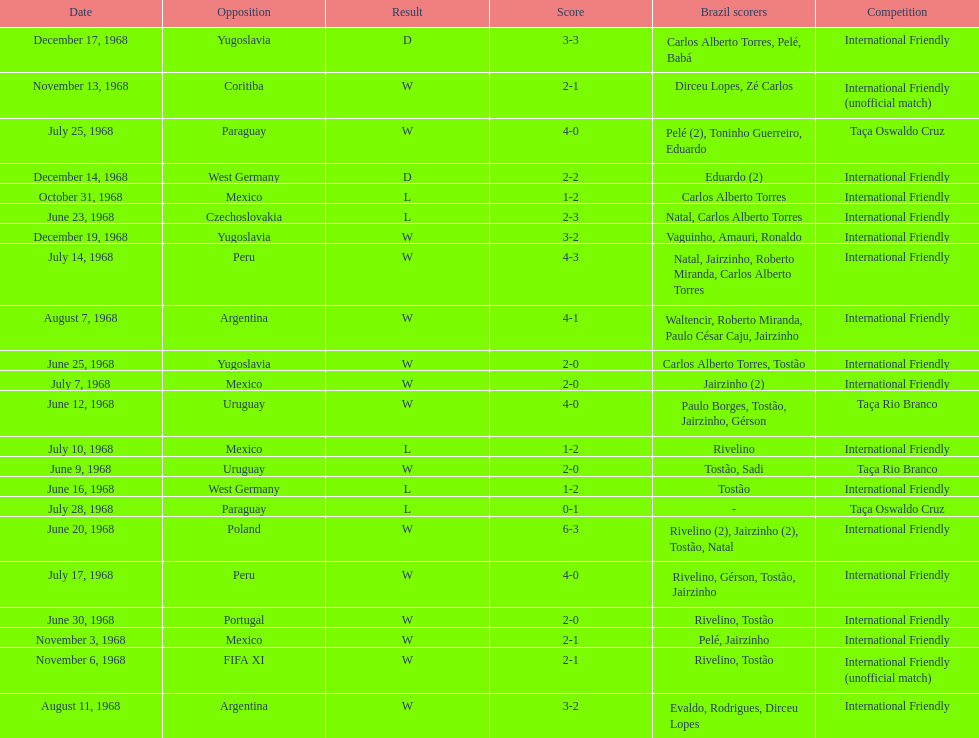Name the first competition ever played by brazil. Taça Rio Branco. 